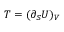Convert formula to latex. <formula><loc_0><loc_0><loc_500><loc_500>T = ( \partial _ { S } U ) _ { V }</formula> 